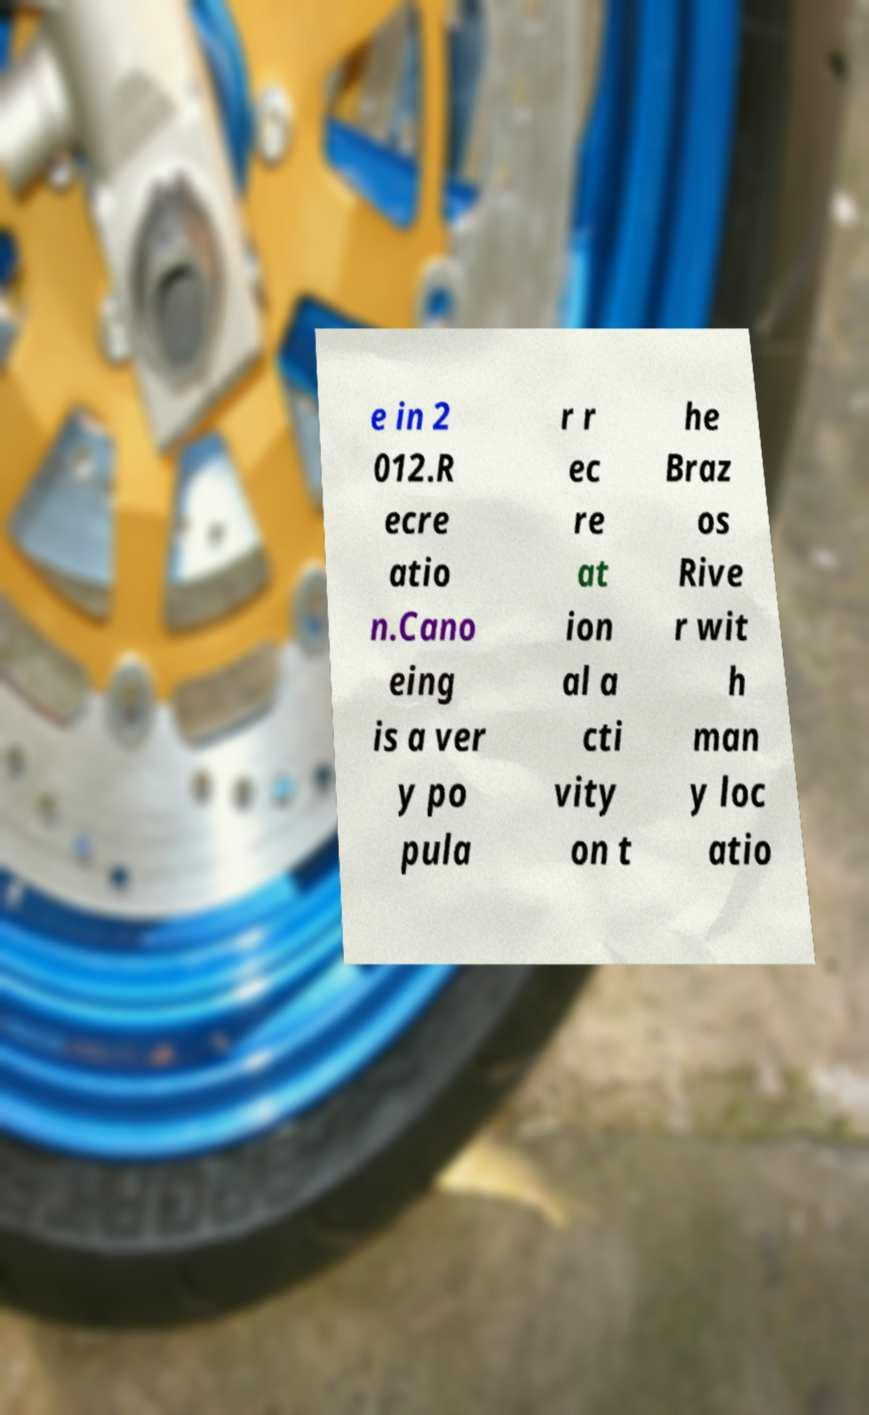There's text embedded in this image that I need extracted. Can you transcribe it verbatim? e in 2 012.R ecre atio n.Cano eing is a ver y po pula r r ec re at ion al a cti vity on t he Braz os Rive r wit h man y loc atio 